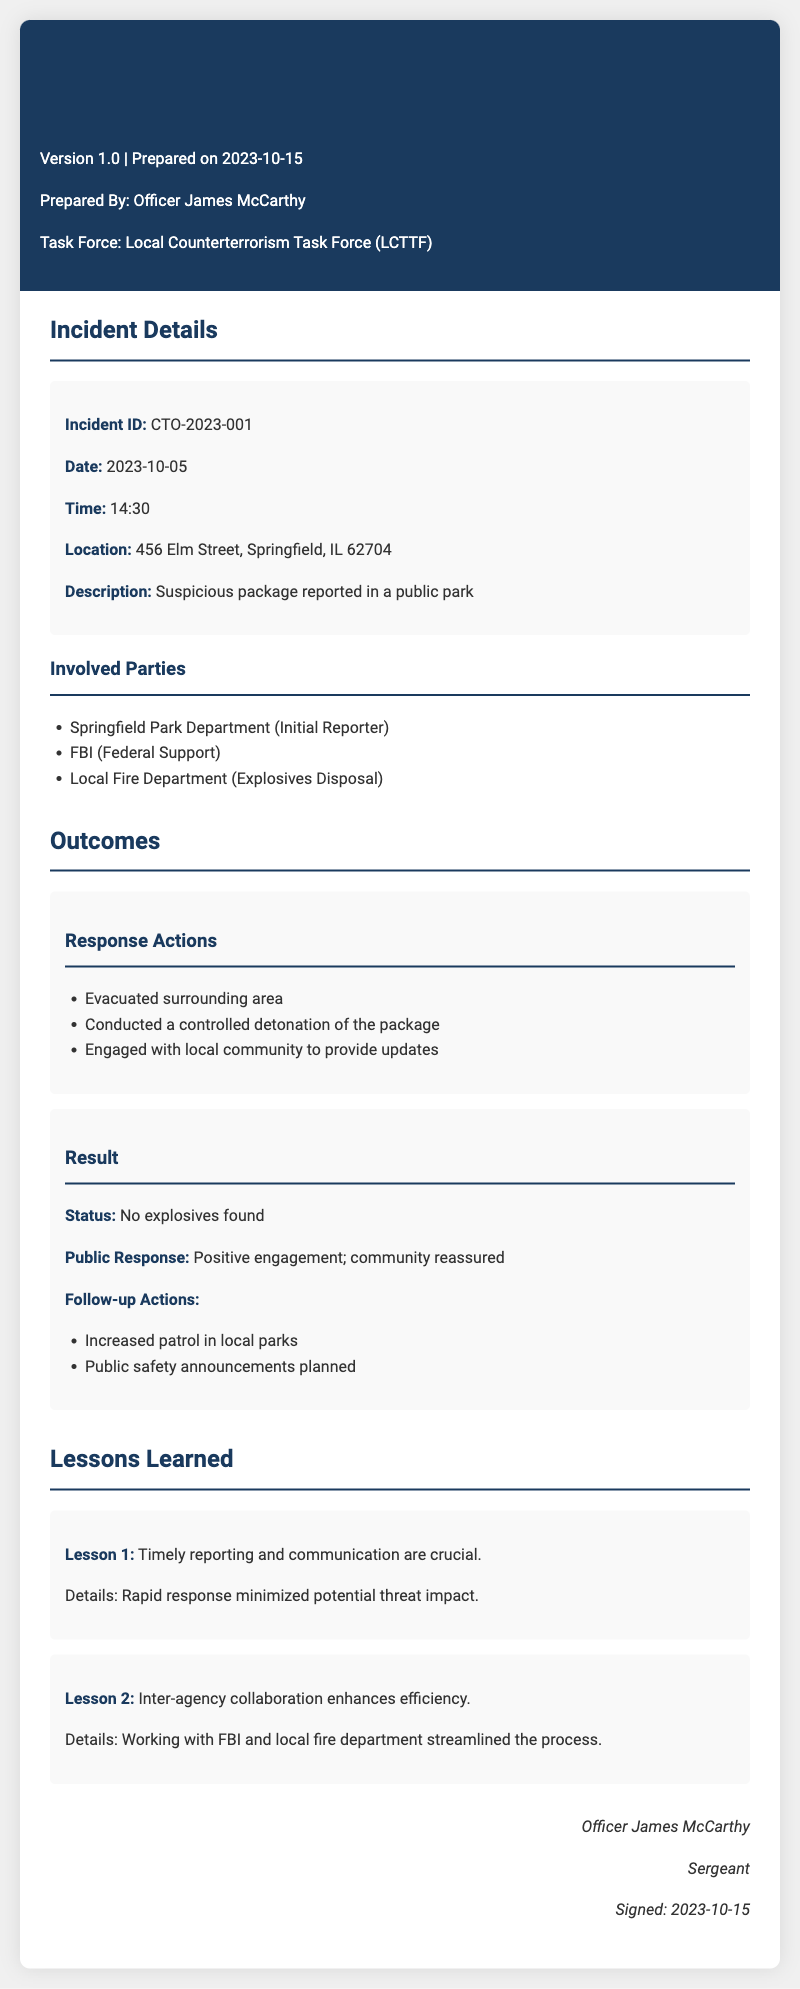what is the incident ID? The incident ID is a unique identifier for the report, stated clearly in the document.
Answer: CTO-2023-001 what was reported on the date of the incident? The document provides a description of the reported incident which is listed under incident details.
Answer: Suspicious package who prepared the incident report? The name of the officer who prepared the report is mentioned in the header section of the document.
Answer: Officer James McCarthy what was the location of the incident? The location is a specific address provided in the incident details section.
Answer: 456 Elm Street, Springfield, IL 62704 what was the status after the incident? The report mentions the result of the investigation into the incident under the outcomes section.
Answer: No explosives found what was one follow-up action taken? This is mentioned in the outcomes section where follow-up actions are listed.
Answer: Increased patrol in local parks how many lessons learned are documented? The number of lessons learned is given in a section dedicated to capturing key insights.
Answer: 2 what is the public response mentioned in the report? The report elaborates on how the community reacted following the incident resolution in the results section.
Answer: Positive engagement; community reassured what is the version of the incident report? The version is printed in the header section of the document.
Answer: 1.0 